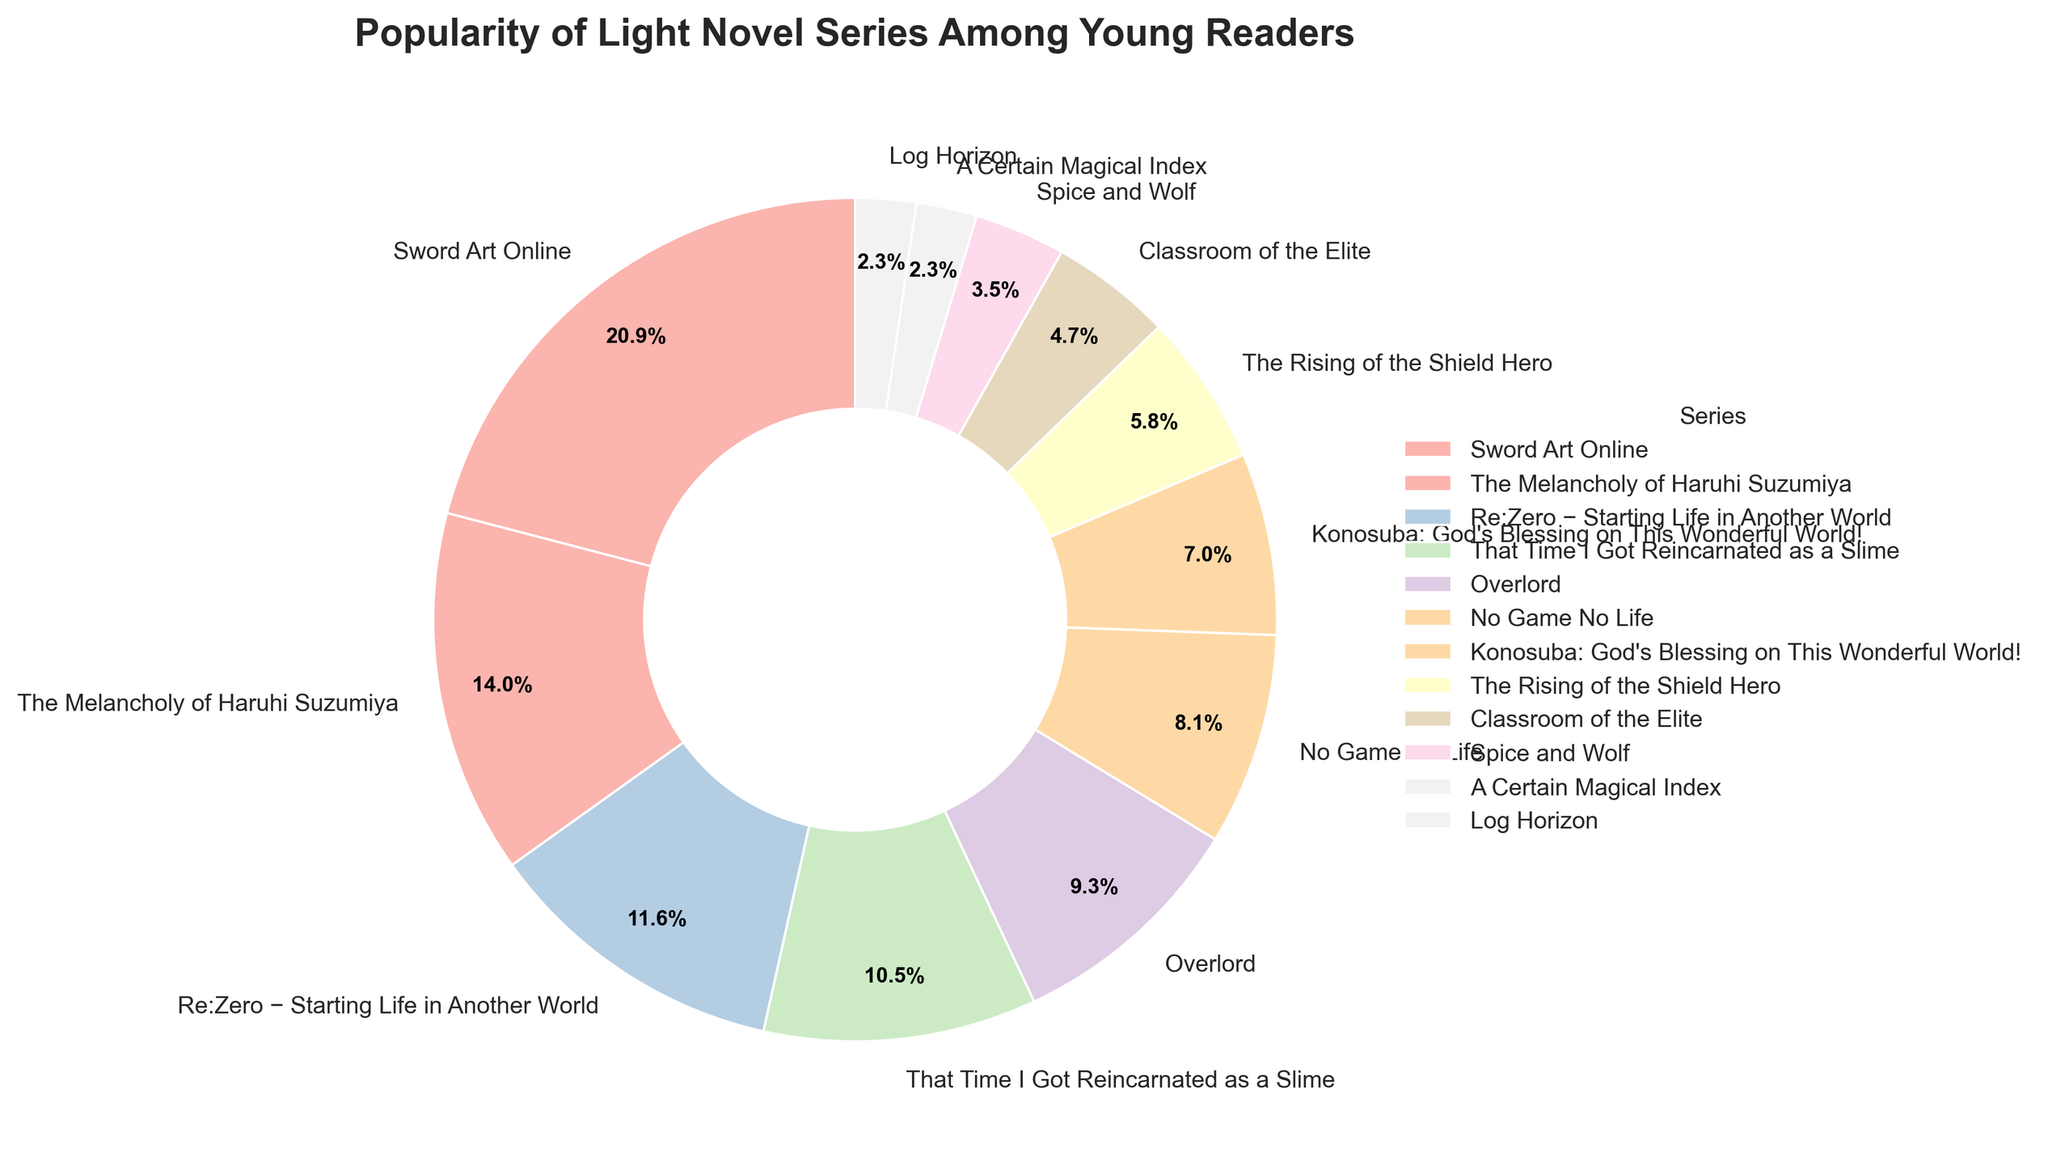Which light novel series is the most popular among young readers? The largest section in the pie chart represents the series with the highest percentage. That series is "Sword Art Online" with 18%.
Answer: Sword Art Online What is the combined popularity percentage of "No Game No Life" and "The Rising of the Shield Hero"? Add the percentages of "No Game No Life" (7%) and "The Rising of the Shield Hero" (5%) together. 7% + 5% = 12%.
Answer: 12% Which series has exactly half the popularity of "Sword Art Online"? "Sword Art Online" has a popularity of 18%. Half of 18% is 9%. The series with 9% popularity is "That Time I Got Reincarnated as a Slime".
Answer: That Time I Got Reincarnated as a Slime How does the popularity of "Re:Zero − Starting Life in Another World" compare to "Overlord" in percentage points? "Re:Zero − Starting Life in Another World" has a popularity of 10%, and "Overlord" has 8%. The difference in popularity is 10% - 8% = 2 percentage points.
Answer: 2 percentage points What is the total percentage of the least popular three series? The least popular three series are "A Certain Magical Index" (2%), "Log Horizon" (2%), and "Spice and Wolf" (3%). Adding their percentages: 2% + 2% + 3% = 7%.
Answer: 7% Which series has a popularity that is closest to the average popularity of all series? To find the average, sum all percentages and divide by the number of series. (18% + 12% + 10% + 9% + 8% + 7% + 6% + 5% + 4% + 3% + 2% + 2%) / 12 = 86% / 12 ≈ 7.17%. "No Game No Life" has a popularity of 7%, which is closest to the average.
Answer: No Game No Life Which series is more popular: "Overlord" or "Konosuba: God's Blessing on This Wonderful World!"? "Overlord" has a popularity of 8%, whereas "Konosuba: God's Blessing on This Wonderful World!" has 6%. Since 8% > 6%, "Overlord" is more popular.
Answer: Overlord What is the difference in popularity between "The Melancholy of Haruhi Suzumiya" and "Classroom of the Elite"? "The Melancholy of Haruhi Suzumiya" has a popularity of 12%, and "Classroom of the Elite" has 4%. The difference is 12% - 4% = 8%.
Answer: 8% If we combine the percentages of "Sword Art Online," "The Melancholy of Haruhi Suzumiya," and "Re:Zero − Starting Life in Another World," what portion of the total do they represent? Combine the percentages 18% + 12% + 10% = 40%. These three series together represent 40% of the total.
Answer: 40% What percentage of young readers prefer series other than the top three most popular ones? The top three popular series are "Sword Art Online" (18%), "The Melancholy of Haruhi Suzumiya" (12%), and "Re:Zero − Starting Life in Another World" (10%). The combined percentage is 18% + 12% + 10% = 40%. To find out the percentage preferring other series, subtract 40% from 100%: 100% - 40% = 60%.
Answer: 60% 